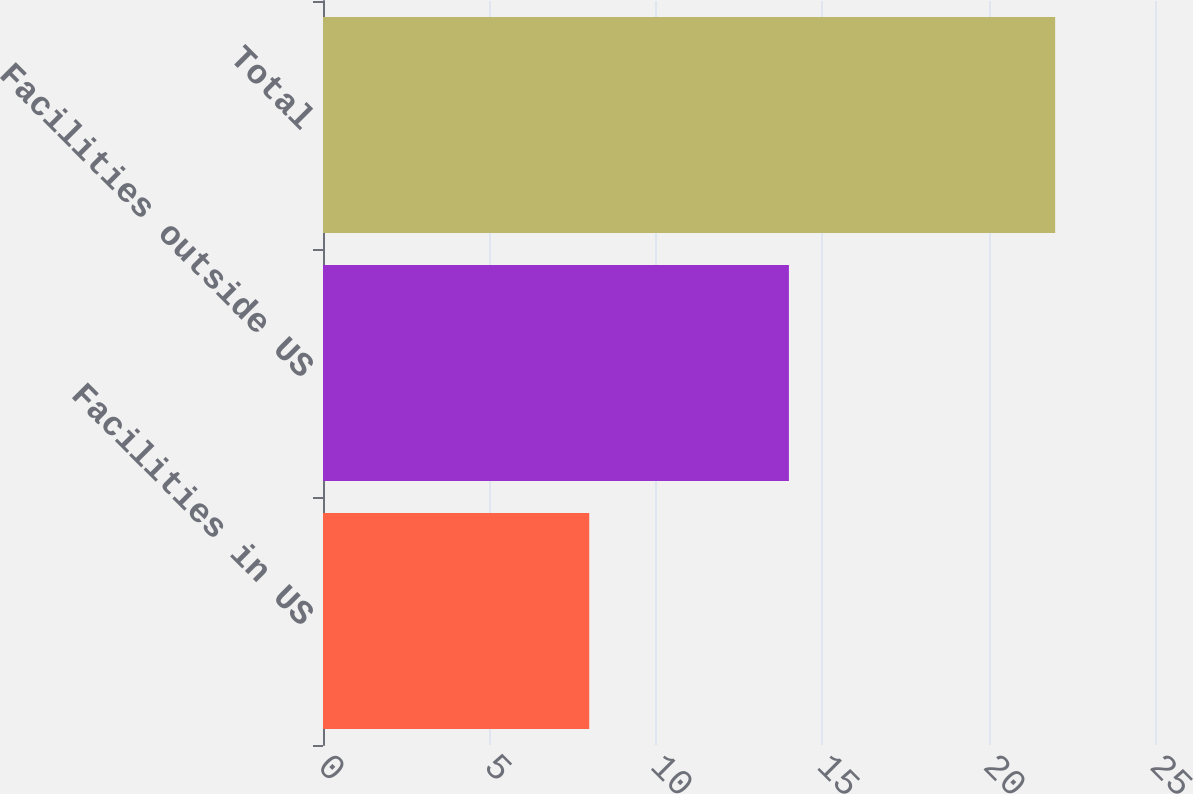Convert chart to OTSL. <chart><loc_0><loc_0><loc_500><loc_500><bar_chart><fcel>Facilities in US<fcel>Facilities outside US<fcel>Total<nl><fcel>8<fcel>14<fcel>22<nl></chart> 